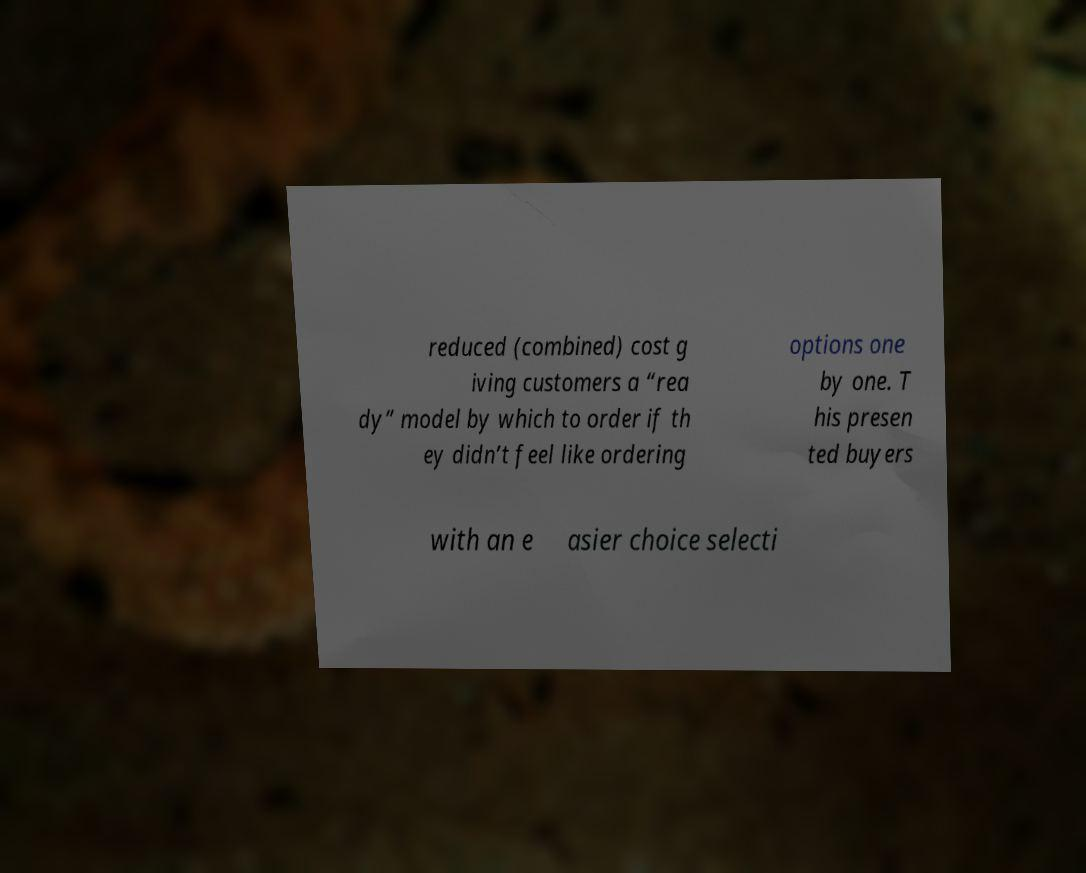Please identify and transcribe the text found in this image. reduced (combined) cost g iving customers a “rea dy” model by which to order if th ey didn’t feel like ordering options one by one. T his presen ted buyers with an e asier choice selecti 